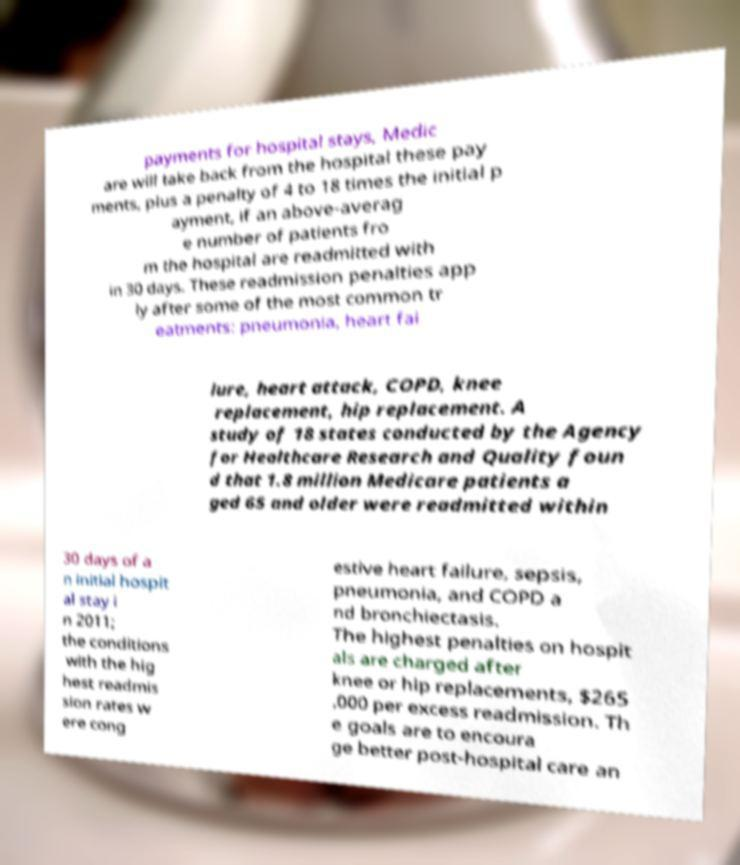Please identify and transcribe the text found in this image. payments for hospital stays, Medic are will take back from the hospital these pay ments, plus a penalty of 4 to 18 times the initial p ayment, if an above-averag e number of patients fro m the hospital are readmitted with in 30 days. These readmission penalties app ly after some of the most common tr eatments: pneumonia, heart fai lure, heart attack, COPD, knee replacement, hip replacement. A study of 18 states conducted by the Agency for Healthcare Research and Quality foun d that 1.8 million Medicare patients a ged 65 and older were readmitted within 30 days of a n initial hospit al stay i n 2011; the conditions with the hig hest readmis sion rates w ere cong estive heart failure, sepsis, pneumonia, and COPD a nd bronchiectasis. The highest penalties on hospit als are charged after knee or hip replacements, $265 ,000 per excess readmission. Th e goals are to encoura ge better post-hospital care an 